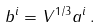Convert formula to latex. <formula><loc_0><loc_0><loc_500><loc_500>b ^ { i } = V ^ { 1 / 3 } a ^ { i } \, .</formula> 